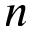Convert formula to latex. <formula><loc_0><loc_0><loc_500><loc_500>n</formula> 